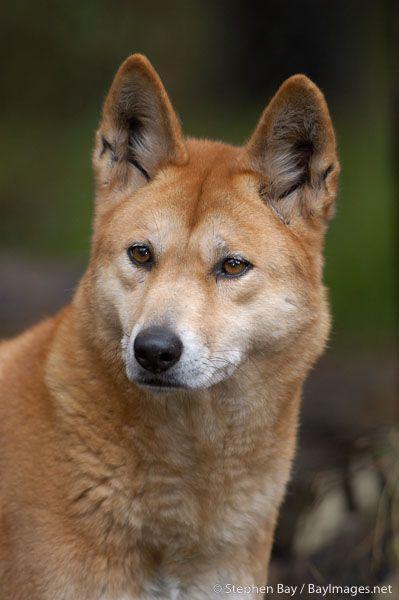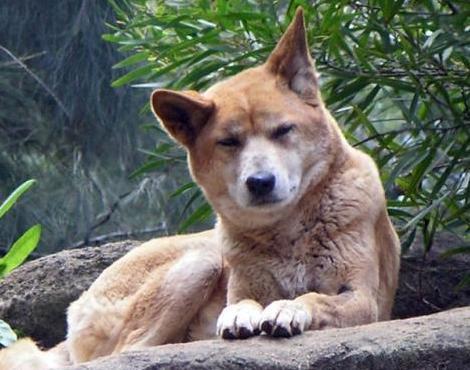The first image is the image on the left, the second image is the image on the right. Given the left and right images, does the statement "There are two dogs" hold true? Answer yes or no. Yes. 